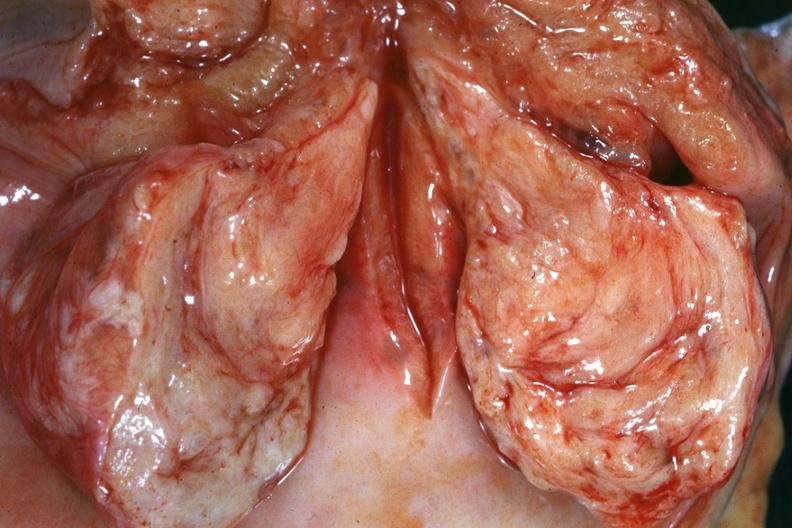what is present?
Answer the question using a single word or phrase. Uterus 